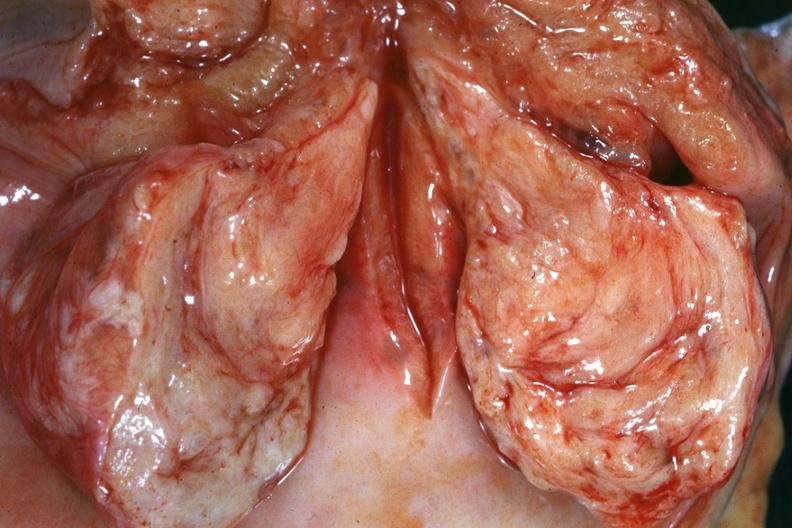what is present?
Answer the question using a single word or phrase. Uterus 